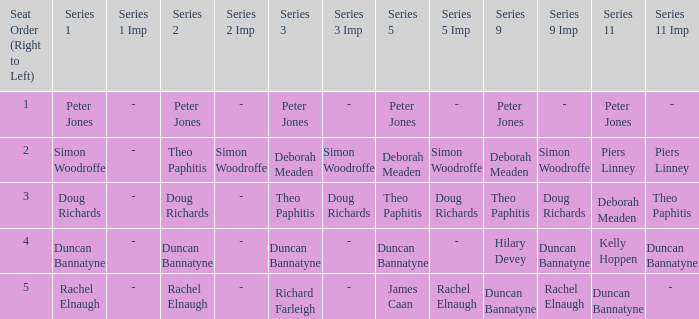Parse the full table. {'header': ['Seat Order (Right to Left)', 'Series 1', 'Series 1 Imp', 'Series 2', 'Series 2 Imp', 'Series 3', 'Series 3 Imp', 'Series 5', 'Series 5 Imp', 'Series 9', 'Series 9 Imp', 'Series 11', 'Series 11 Imp'], 'rows': [['1', 'Peter Jones', '-', 'Peter Jones', '-', 'Peter Jones', '-', 'Peter Jones', '-', 'Peter Jones', '-', 'Peter Jones', '-'], ['2', 'Simon Woodroffe', '-', 'Theo Paphitis', 'Simon Woodroffe', 'Deborah Meaden', 'Simon Woodroffe', 'Deborah Meaden', 'Simon Woodroffe', 'Deborah Meaden', 'Simon Woodroffe', 'Piers Linney', 'Piers Linney'], ['3', 'Doug Richards', '-', 'Doug Richards', '-', 'Theo Paphitis', 'Doug Richards', 'Theo Paphitis', 'Doug Richards', 'Theo Paphitis', 'Doug Richards', 'Deborah Meaden', 'Theo Paphitis'], ['4', 'Duncan Bannatyne', '-', 'Duncan Bannatyne', '-', 'Duncan Bannatyne', '-', 'Duncan Bannatyne', '-', 'Hilary Devey', 'Duncan Bannatyne', 'Kelly Hoppen', 'Duncan Bannatyne'], ['5', 'Rachel Elnaugh', '-', 'Rachel Elnaugh', '-', 'Richard Farleigh', '-', 'James Caan', 'Rachel Elnaugh', 'Duncan Bannatyne', 'Rachel Elnaugh', 'Duncan Bannatyne', '- ']]} Which Series 1 has a Series 11 of peter jones? Peter Jones. 